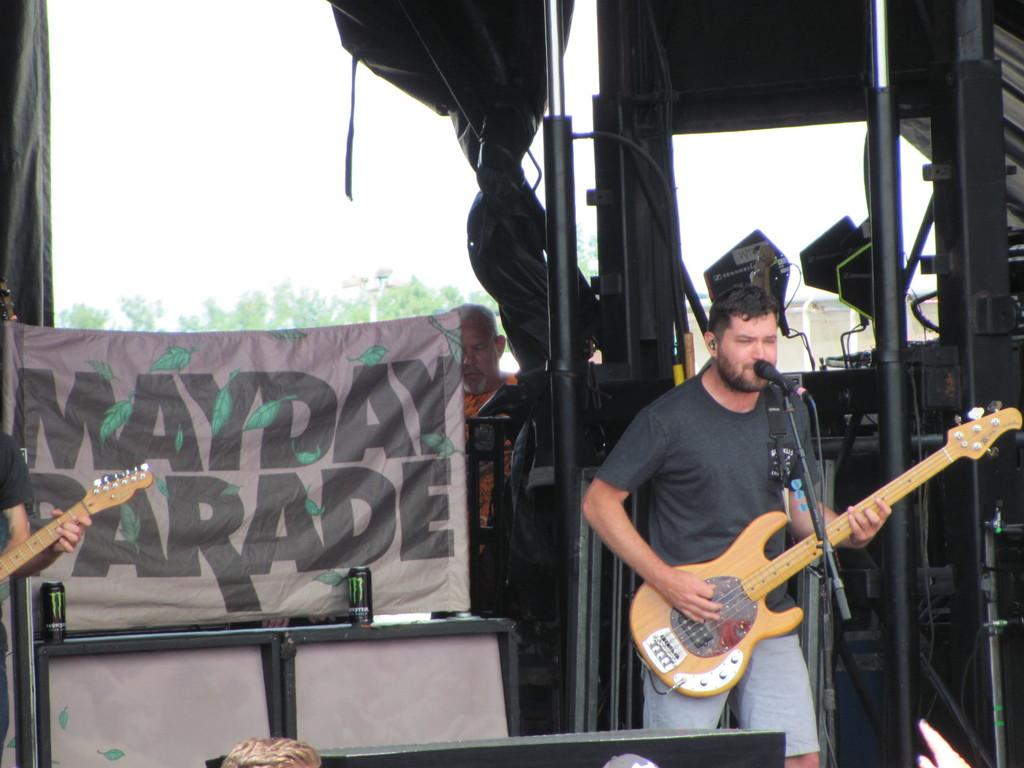What is the person in the image doing? The person is standing and playing the guitar. What is the person holding in the image? The person is holding a guitar. What can be seen in the background of the image? There is a tree, a banner, and the sky visible in the background of the image. Can you see the person's tongue sticking out while playing the guitar in the image? There is no indication in the image that the person's tongue is sticking out while playing the guitar. 